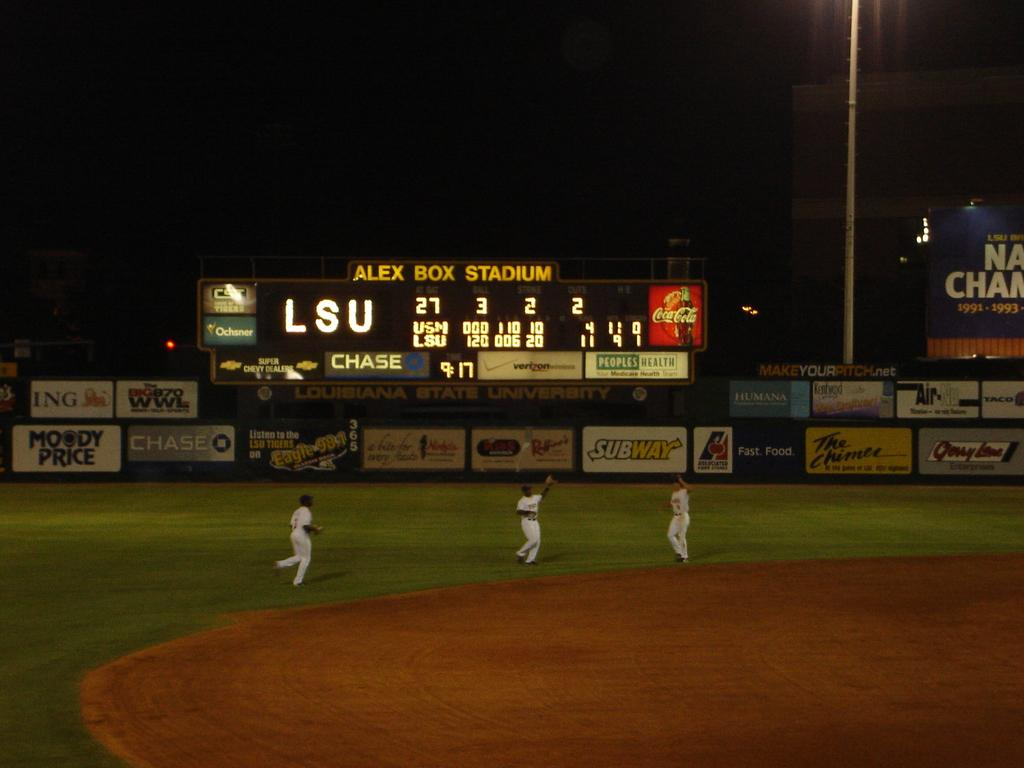<image>
Write a terse but informative summary of the picture. Three baseball players playing a night game outside in Alex Box Stadium. 